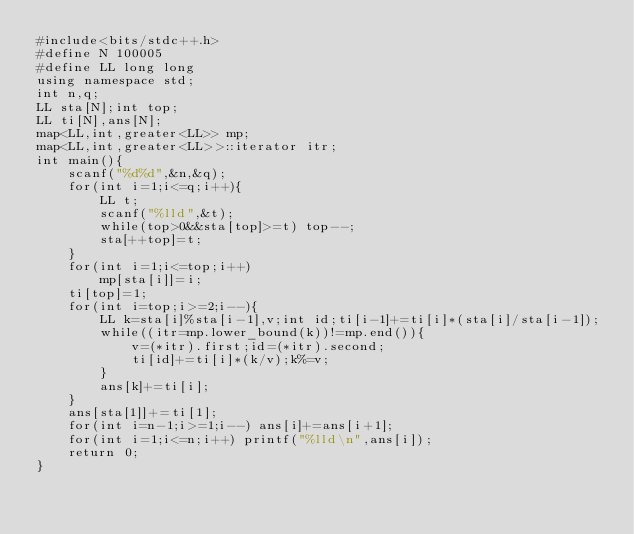Convert code to text. <code><loc_0><loc_0><loc_500><loc_500><_C++_>#include<bits/stdc++.h>
#define N 100005
#define LL long long
using namespace std;
int n,q;
LL sta[N];int top;
LL ti[N],ans[N];
map<LL,int,greater<LL>> mp;
map<LL,int,greater<LL>>::iterator itr; 
int main(){
	scanf("%d%d",&n,&q);
	for(int i=1;i<=q;i++){
		LL t;
		scanf("%lld",&t);
		while(top>0&&sta[top]>=t) top--;
		sta[++top]=t;
	}
	for(int i=1;i<=top;i++)
		mp[sta[i]]=i;
	ti[top]=1;
	for(int i=top;i>=2;i--){
		LL k=sta[i]%sta[i-1],v;int id;ti[i-1]+=ti[i]*(sta[i]/sta[i-1]);
		while((itr=mp.lower_bound(k))!=mp.end()){
			v=(*itr).first;id=(*itr).second;
			ti[id]+=ti[i]*(k/v);k%=v;
		}
		ans[k]+=ti[i];
	}
	ans[sta[1]]+=ti[1];
	for(int i=n-1;i>=1;i--) ans[i]+=ans[i+1];
	for(int i=1;i<=n;i++) printf("%lld\n",ans[i]);
	return 0;
}</code> 